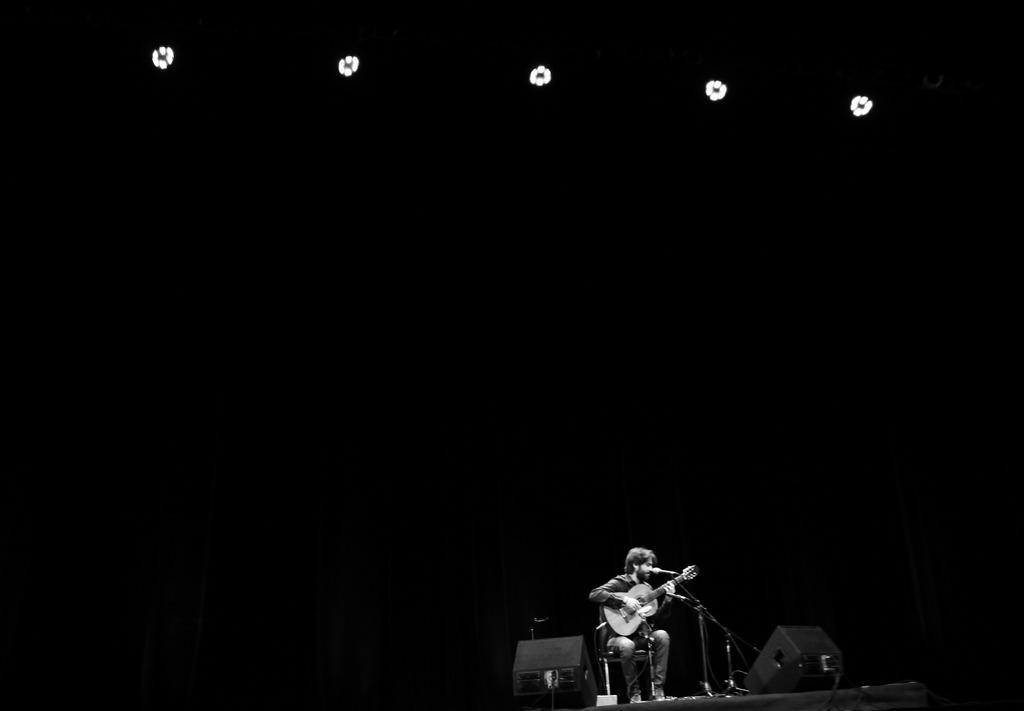How would you summarize this image in a sentence or two? On top there are focusing lights. This person is sitting on chair and playing guitar in-front of mic. 